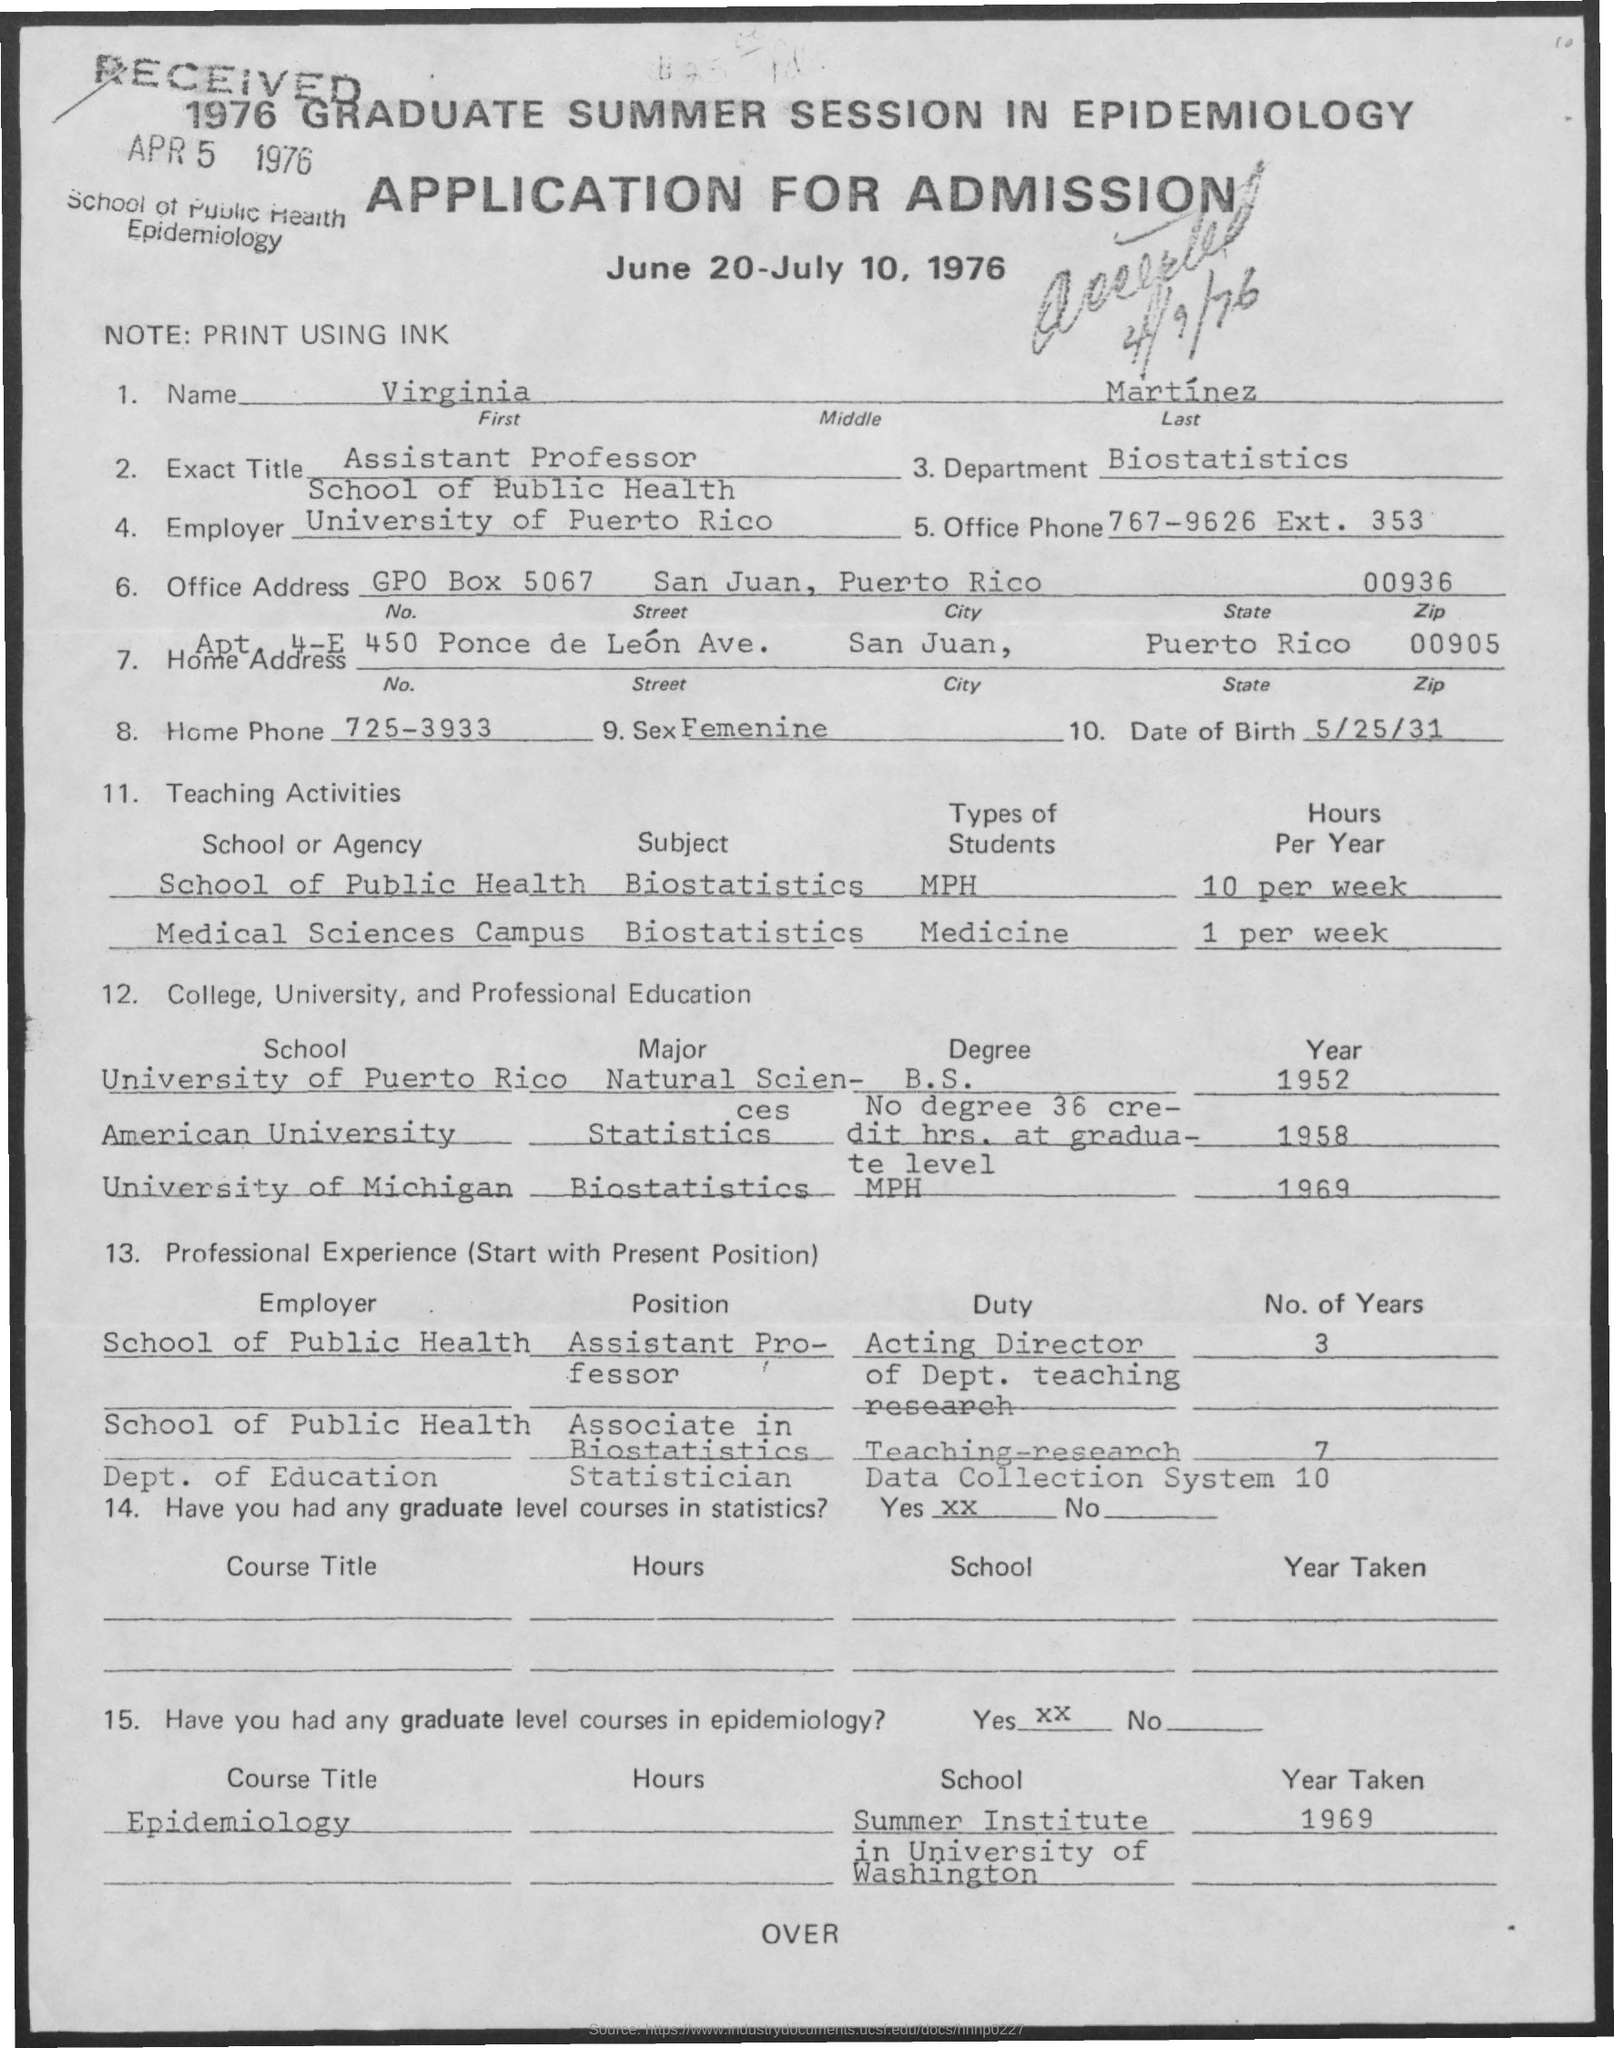Indicate a few pertinent items in this graphic. The state is a political entity that is recognized by the government and has a defined set of characteristics and responsibilities. Puerto Rico is a territory that has been recognized as a state by the United States government but does not have the same level of autonomy as a full-fledged state. The department is known as Biostatistics. The office phone number is 767-9626, with an extension of 353. I am an Assistant Professor. The title of the document is Application for Admission. 